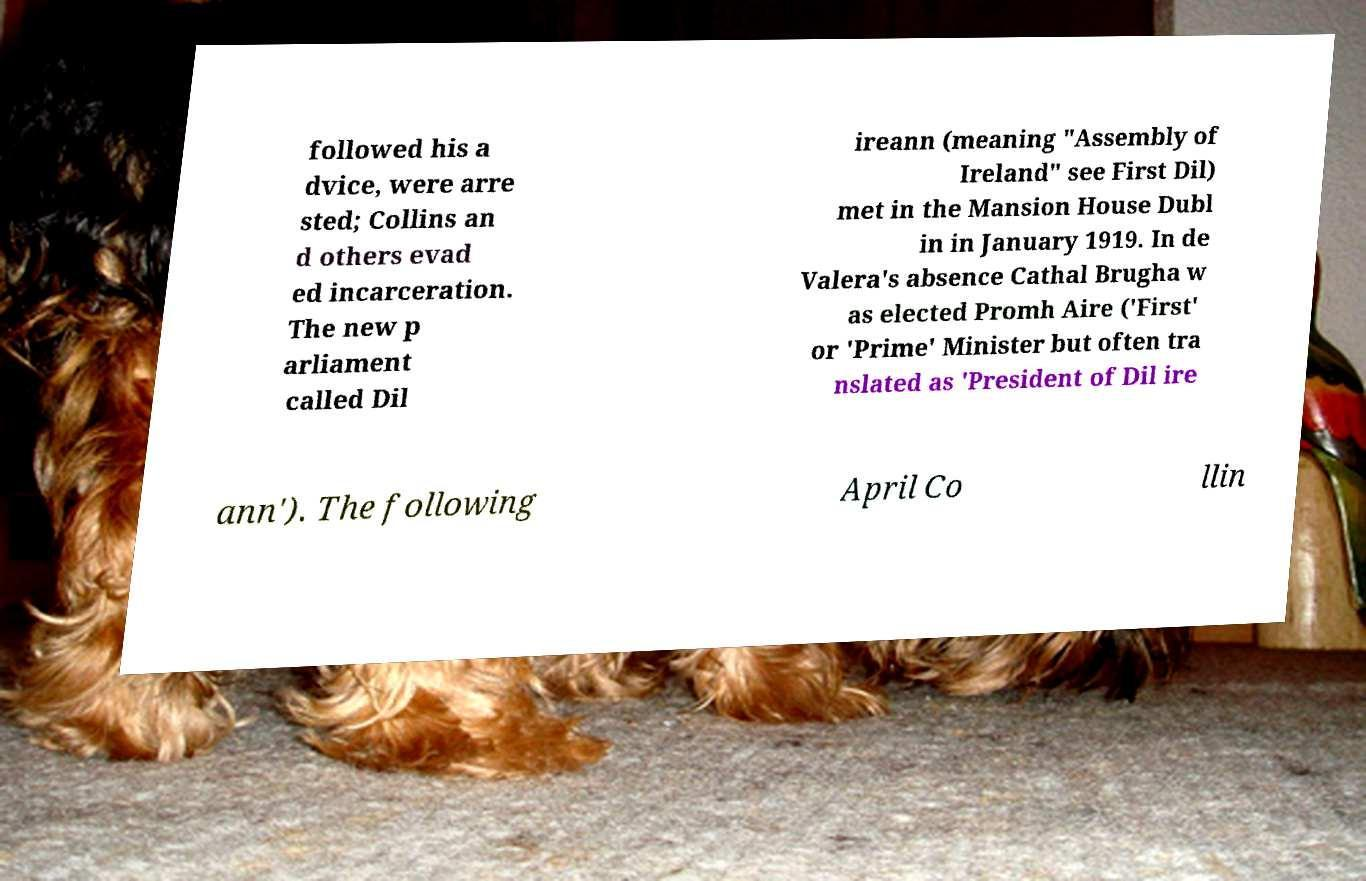What messages or text are displayed in this image? I need them in a readable, typed format. followed his a dvice, were arre sted; Collins an d others evad ed incarceration. The new p arliament called Dil ireann (meaning "Assembly of Ireland" see First Dil) met in the Mansion House Dubl in in January 1919. In de Valera's absence Cathal Brugha w as elected Promh Aire ('First' or 'Prime' Minister but often tra nslated as 'President of Dil ire ann'). The following April Co llin 